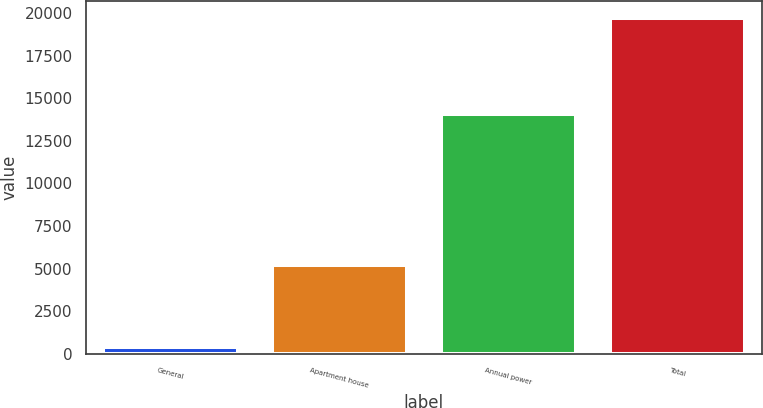Convert chart. <chart><loc_0><loc_0><loc_500><loc_500><bar_chart><fcel>General<fcel>Apartment house<fcel>Annual power<fcel>Total<nl><fcel>425<fcel>5240<fcel>14076<fcel>19741<nl></chart> 